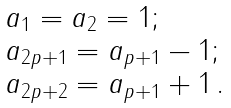<formula> <loc_0><loc_0><loc_500><loc_500>\begin{array} { l } a _ { 1 } = a _ { 2 } = 1 ; \\ a _ { 2 p + 1 } = a _ { p + 1 } - 1 ; \\ a _ { 2 p + 2 } = a _ { p + 1 } + 1 \, . \end{array}</formula> 